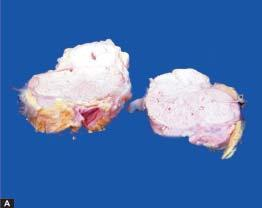what is matted mass of lymph nodes surrounded by?
Answer the question using a single word or phrase. Increased fat 